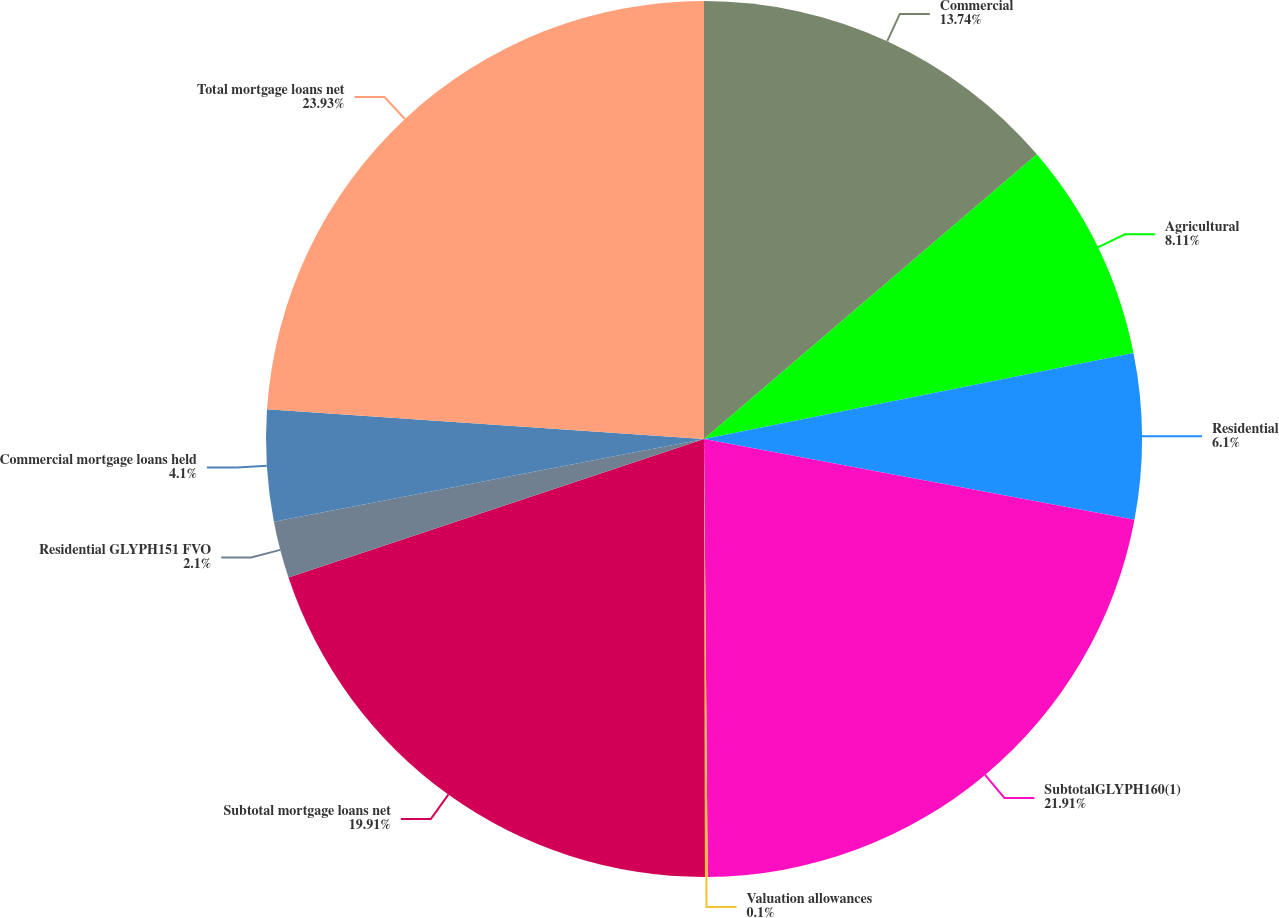<chart> <loc_0><loc_0><loc_500><loc_500><pie_chart><fcel>Commercial<fcel>Agricultural<fcel>Residential<fcel>SubtotalGLYPH160(1)<fcel>Valuation allowances<fcel>Subtotal mortgage loans net<fcel>Residential GLYPH151 FVO<fcel>Commercial mortgage loans held<fcel>Total mortgage loans net<nl><fcel>13.74%<fcel>8.11%<fcel>6.1%<fcel>21.91%<fcel>0.1%<fcel>19.91%<fcel>2.1%<fcel>4.1%<fcel>23.92%<nl></chart> 